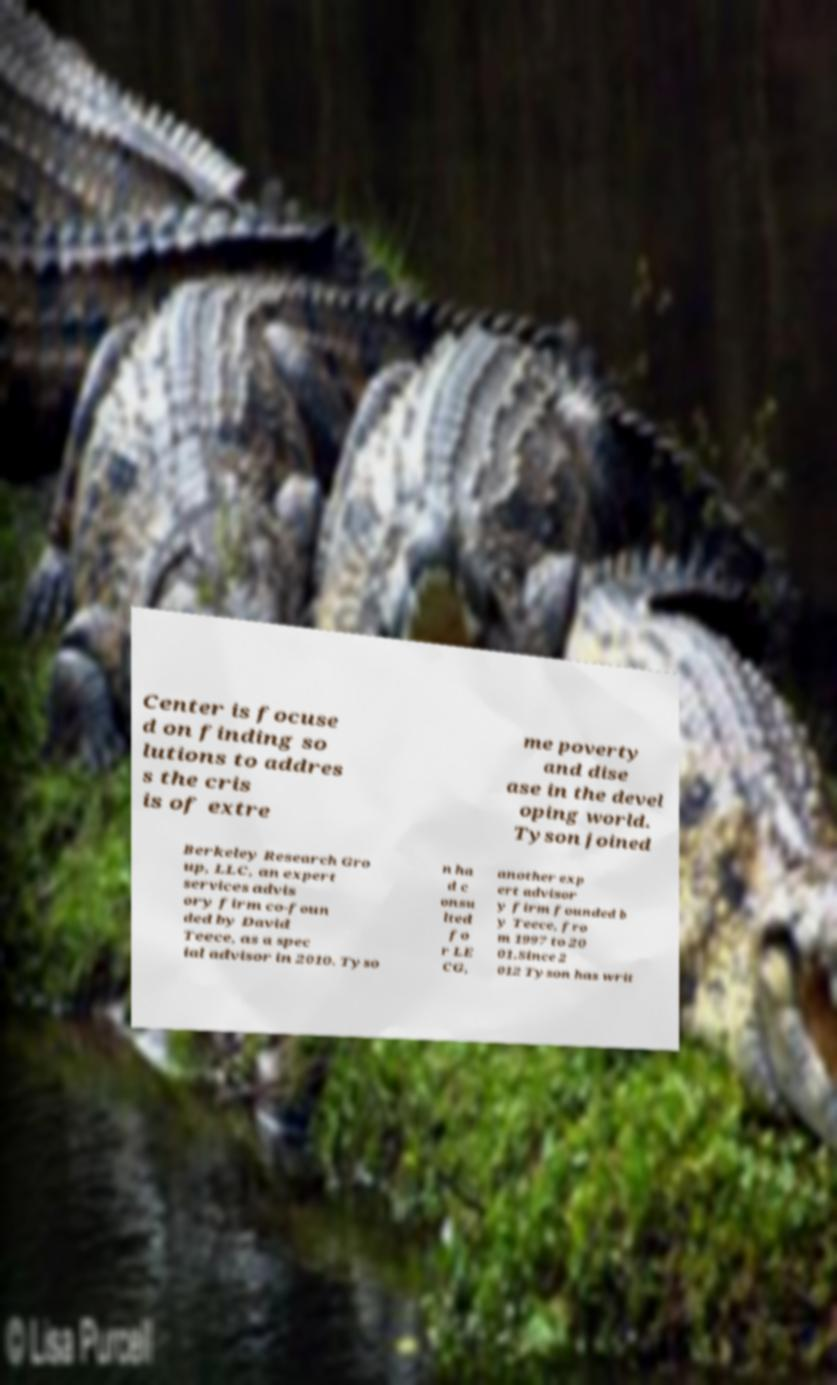Please read and relay the text visible in this image. What does it say? Center is focuse d on finding so lutions to addres s the cris is of extre me poverty and dise ase in the devel oping world. Tyson joined Berkeley Research Gro up, LLC, an expert services advis ory firm co-foun ded by David Teece, as a spec ial advisor in 2010. Tyso n ha d c onsu lted fo r LE CG, another exp ert advisor y firm founded b y Teece, fro m 1997 to 20 01.Since 2 012 Tyson has writ 